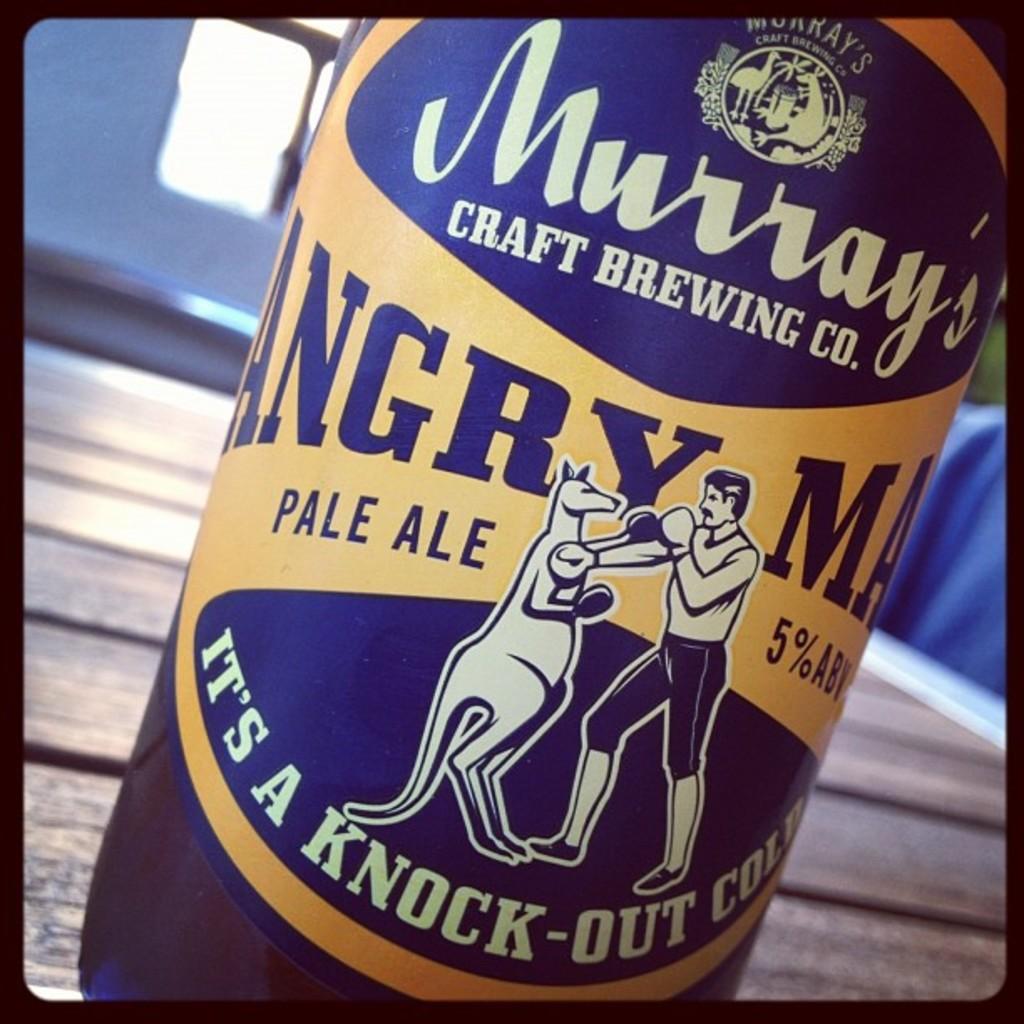What brewing company made this beer?
Offer a terse response. Murray's. What alcohol percentage is this beer?
Keep it short and to the point. 5%. 